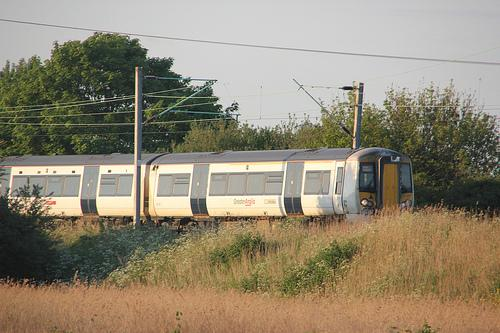How many power lines are above the train in the image? There are single and group power lines above the train, totaling at least two or more. Analyze the interaction of objects in the image and explain their relevance. The train is the focal point, surrounded by natural elements like grass, trees, and flowers. Power lines and poles show the infrastructure needed to run the train, completing the scene of a tram train in operation. What type of vegetation can be seen near the train in the image? There is dry grass, green bushes, flowers, and green trees near the train. Can you infer the train's purpose based on the image? The train appears to be a tram train, possibly used for public transportation or cargo transportation. Is there any text on the train, and if so, what does it say or indicate? There are words on the side of the train, but the specific text is not provided. What color is the sky in the image and what does it suggest about the weather? The sky is grey and blueish grey, suggesting that it might be cloudy or overcast. What is the sentiment of the image based on the colors and surrounding environment? The sentiment of the image is calm, with the muted colors of the train, grey sky, and natural surroundings giving a tranquil sense. Identify the number of doors and windows on the train in the image. There are at least 5 doors and various windows, including a front windshield, a two-pane window, and a four-pane window. Briefly describe the surroundings of the train in the image. The train is surrounded by dry grass, green trees, power lines, and a grey sky. There are flowers, bushes, and a large tree in the background. What are the prominent colors of the train in the image? The train is white, black, blue, and has a yellow door on the front. 